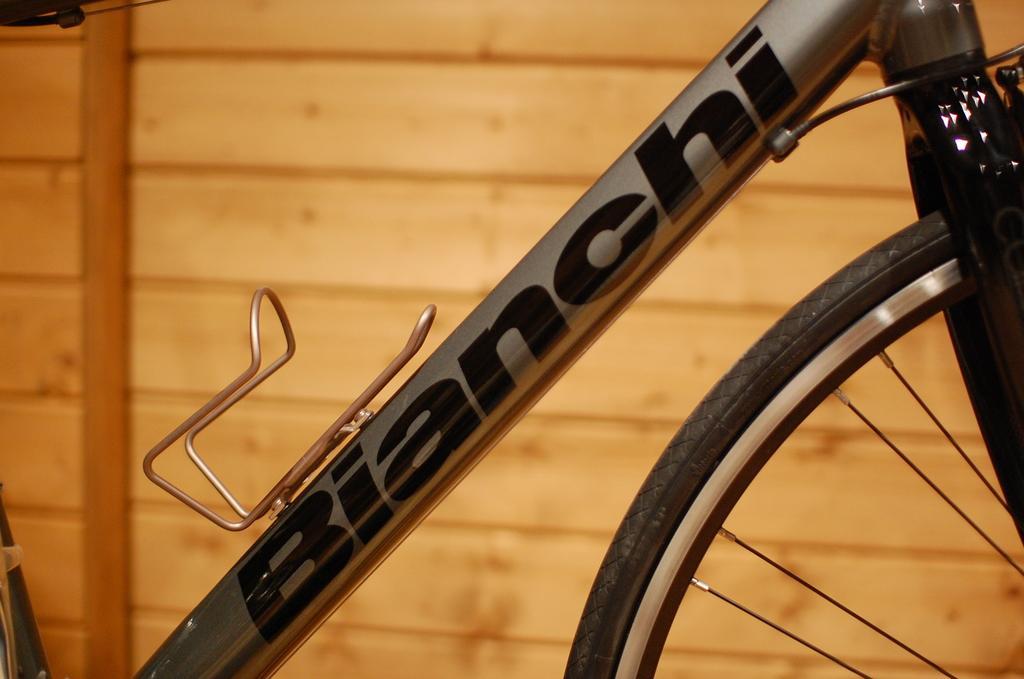Can you describe this image briefly? In the picture we can see a part of the bicycle with a part of the tire to it and behind it we can see the wooden wall. 